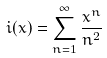<formula> <loc_0><loc_0><loc_500><loc_500>\L i ( x ) = \sum _ { n = 1 } ^ { \infty } \frac { x ^ { n } } { n ^ { 2 } }</formula> 